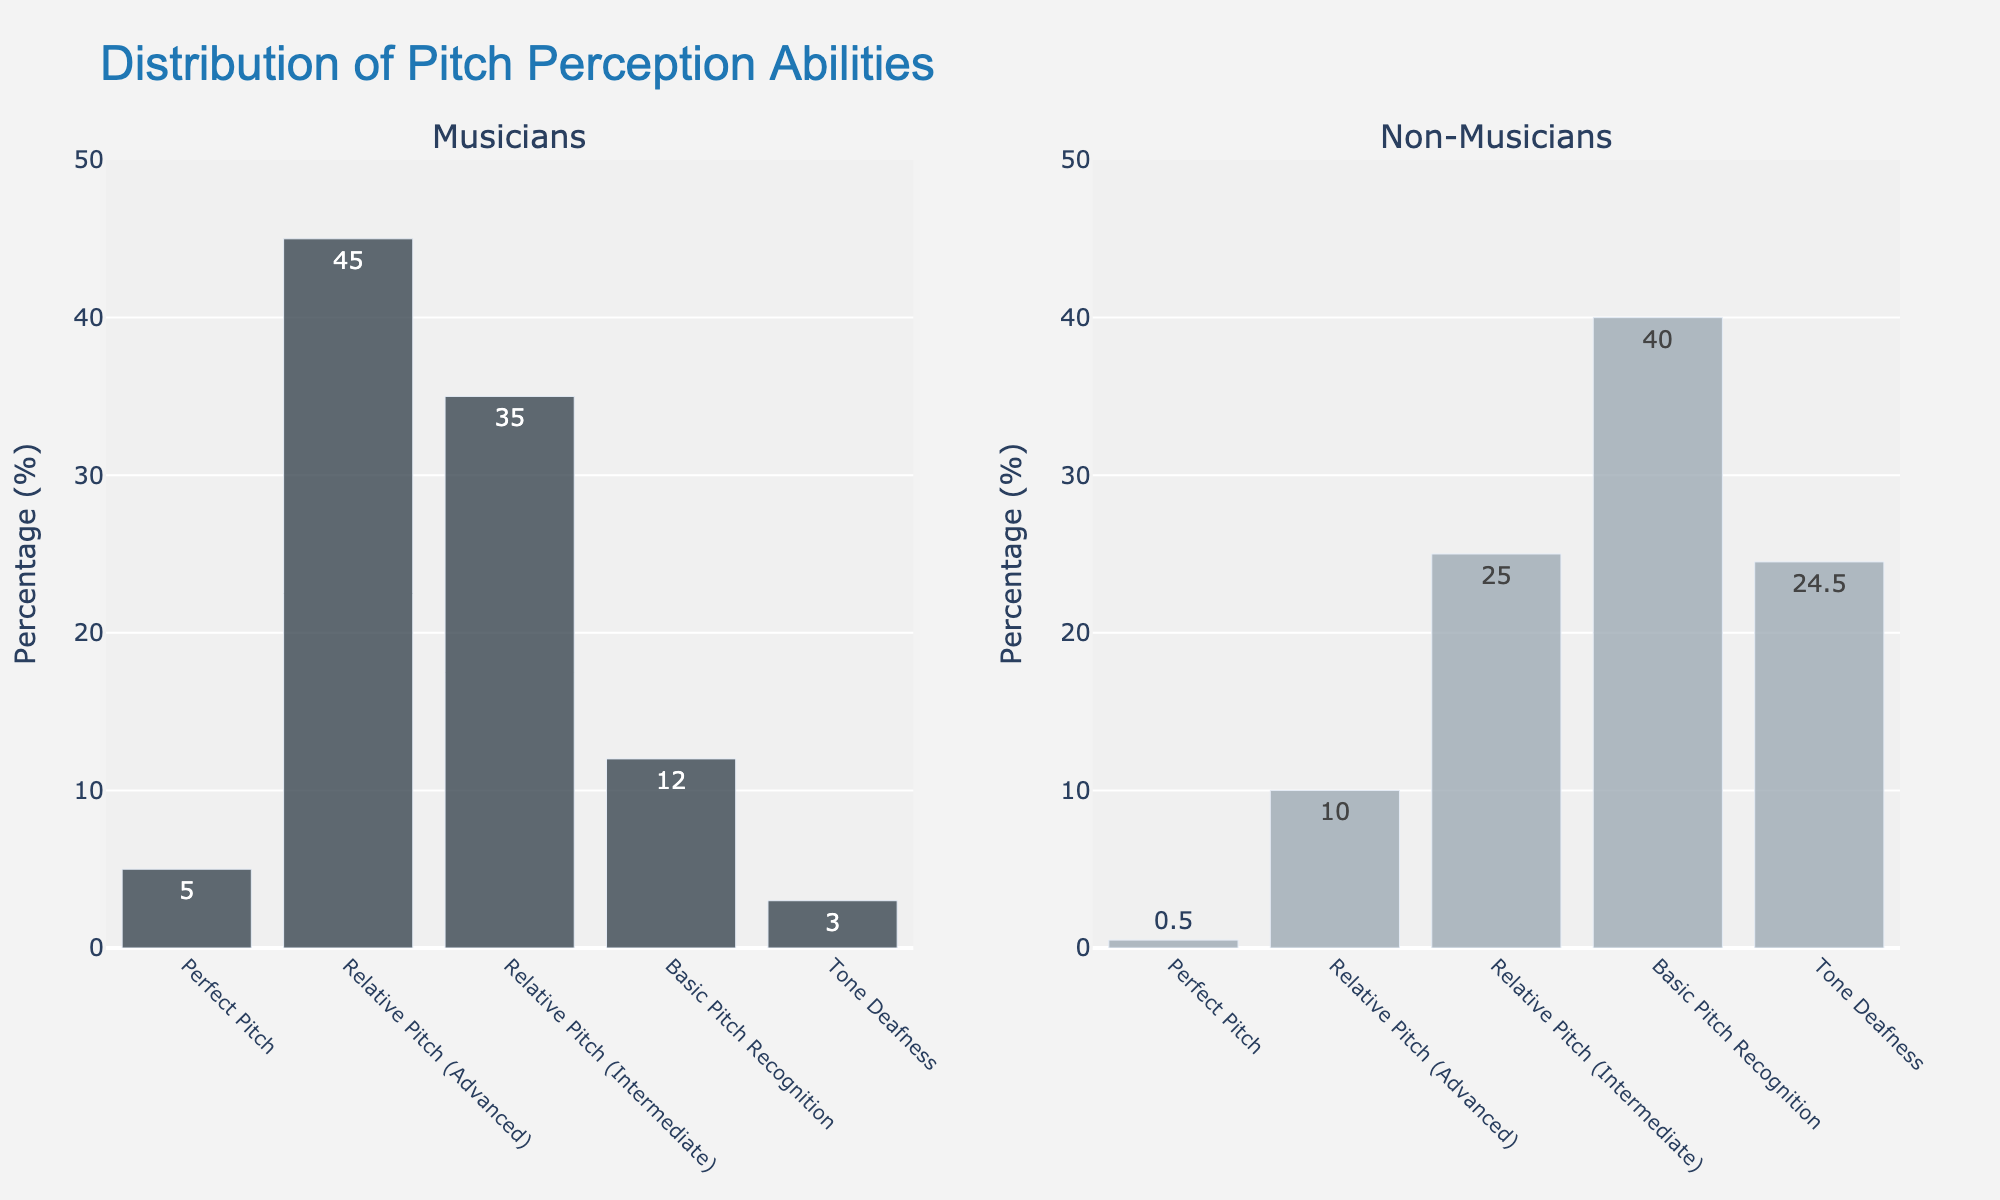Which group has the highest percentage in the "Relative Pitch (Advanced)" category? For the "Relative Pitch (Advanced)" category, the value for musicians is 45%, and for non-musicians, it is 10%. Comparing them, the musicians have the higher percentage.
Answer: Musicians What is the total percentage of musicians in the "Perfect Pitch" and "Relative Pitch (Advanced)" categories? Adding the percentages for musicians in "Perfect Pitch" (5%) and "Relative Pitch (Advanced)" (45%) gives 5 + 45 = 50%.
Answer: 50% How much greater is the percentage of non-musicians who are "Tone Deaf" compared to musicians? The percentage of non-musicians who are "Tone Deaf" is 24.5%, and for musicians, it is 3%. Subtracting these values, 24.5 - 3 = 21.5%.
Answer: 21.5% Which group has a higher percentage in the "Basic Pitch Recognition" category, and by how much? In the "Basic Pitch Recognition" category, musicians have 12%, and non-musicians have 40%. Subtracting these values, 40 - 12 = 28%. Non-musicians have a higher percentage by 28%.
Answer: Non-musicians by 28% What is the average percentage of "Relative Pitch (Advanced)" and "Relative Pitch (Intermediate)" for musicians? The percentage of musicians in "Relative Pitch (Advanced)" is 45%, and in "Relative Pitch (Intermediate)" is 35%. Adding these and dividing by 2, (45 + 35) / 2 = 40%.
Answer: 40% In which category is the difference in percentages between musicians and non-musicians most significant? For each category, calculate the difference in percentages: "Perfect Pitch" (5 - 0.5 = 4.5%), "Relative Pitch (Advanced)" (45 - 10 = 35%), "Relative Pitch (Intermediate)" (35 - 25 = 10%), "Basic Pitch Recognition" (12 - 40 = 28%), "Tone Deafness" (24.5 - 3 = 21.5%). The most significant difference is in the "Relative Pitch (Advanced)" category with 35%.
Answer: Relative Pitch (Advanced) If you combine "Intermediate" and "Advanced" pitch recognition categories, which group has a higher total percentage? For musicians, the combined percentage is 45% (Advanced) + 35% (Intermediate) = 80%. For non-musicians, it is 10% (Advanced) + 25% (Intermediate) = 35%. Musicians have a higher total percentage.
Answer: Musicians What percentage of non-musicians fall into the top two pitch perception categories? The top two categories for non-musicians are "Perfect Pitch" and "Relative Pitch (Advanced)" with 0.5% and 10% respectively. Adding them, 0.5 + 10 = 10.5%.
Answer: 10.5% Across all categories, which group shows the most diversity in percentages, and what is the range? The range is the difference between the highest and lowest percentages for each group. For musicians: highest 45% (Advanced), lowest 3% (Tone Deaf), range = 45 - 3 = 42%. For non-musicians: highest 40% (Basic), lowest 0.5% (Perfect Pitch), range = 40 - 0.5 = 39.5%. Musicians show the most diversity with a range of 42%.
Answer: Musicians with a range of 42% 